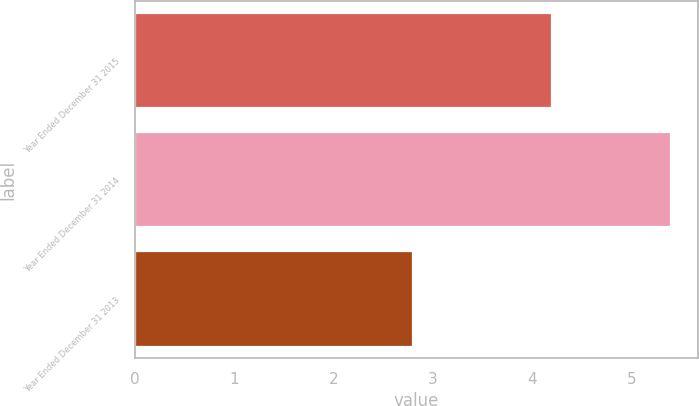Convert chart. <chart><loc_0><loc_0><loc_500><loc_500><bar_chart><fcel>Year Ended December 31 2015<fcel>Year Ended December 31 2014<fcel>Year Ended December 31 2013<nl><fcel>4.2<fcel>5.4<fcel>2.8<nl></chart> 